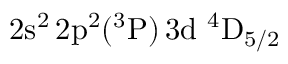Convert formula to latex. <formula><loc_0><loc_0><loc_500><loc_500>2 s ^ { 2 } \, 2 p ^ { 2 } ( ^ { 3 } P ) \, 3 d ^ { 4 } D _ { 5 / 2 }</formula> 